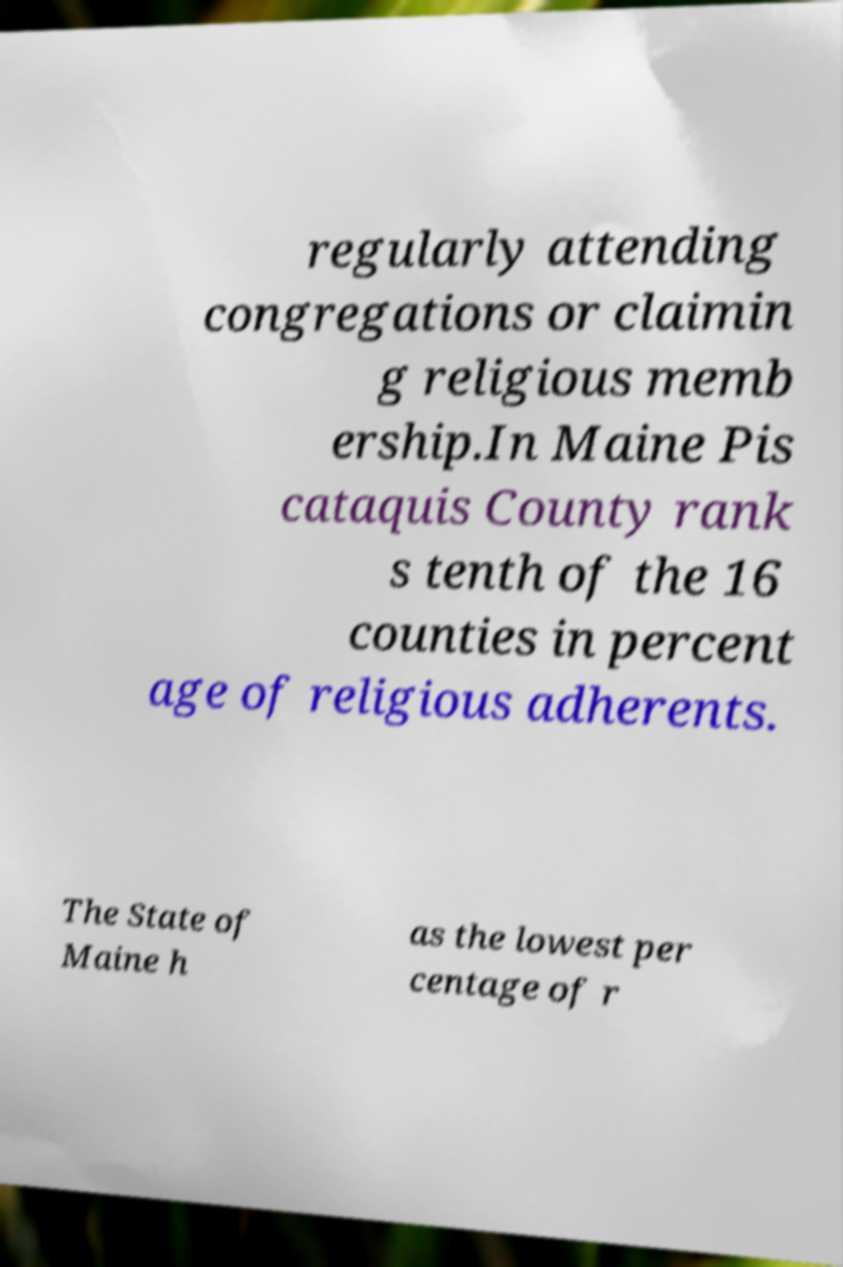Please identify and transcribe the text found in this image. regularly attending congregations or claimin g religious memb ership.In Maine Pis cataquis County rank s tenth of the 16 counties in percent age of religious adherents. The State of Maine h as the lowest per centage of r 